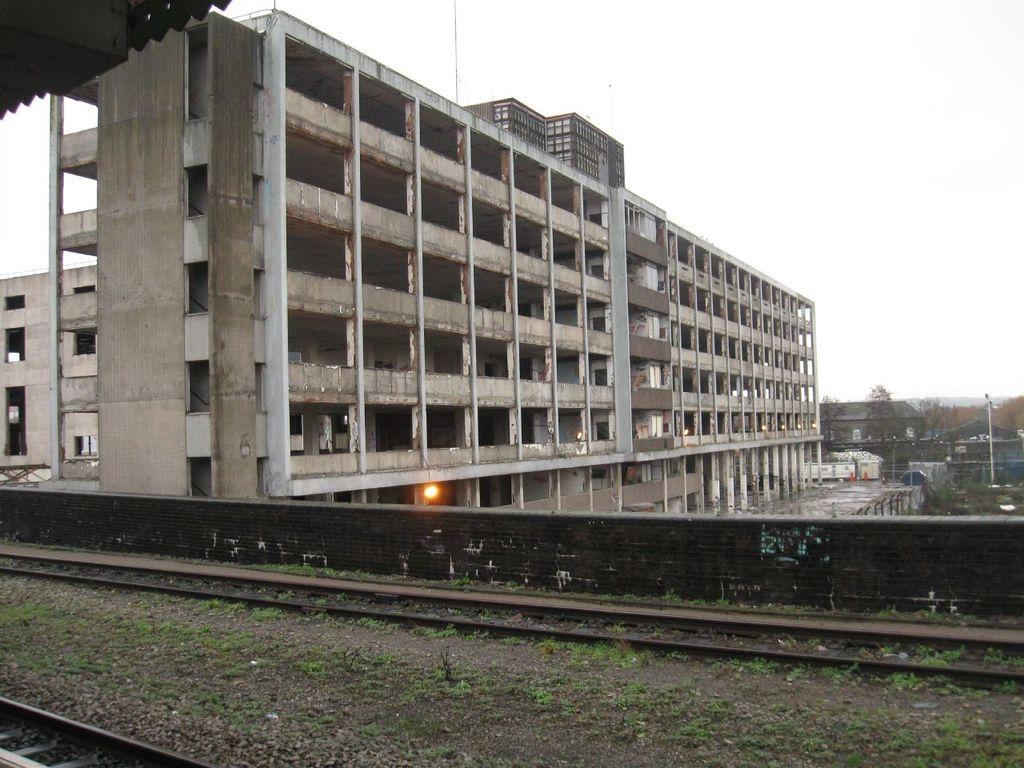Describe this image in one or two sentences. In this image in the front there are railway tracks and in the center there is a wall. In the background there is fence and there are buildings and trees. 